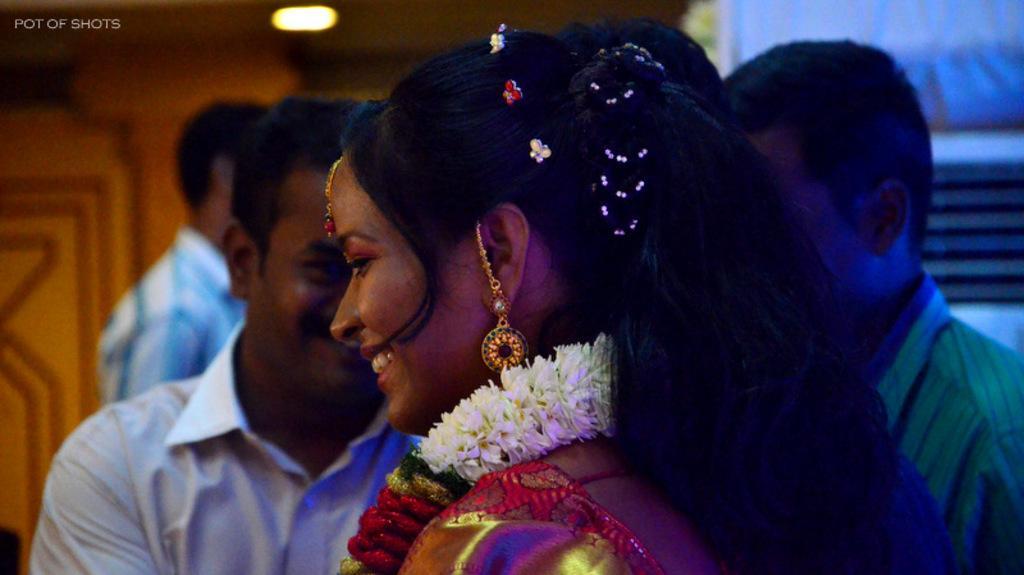Could you give a brief overview of what you see in this image? This picture seems to be clicked inside the room. In the foreground we can see a woman wearing a garland, smiling and seems to be standing and we can see the group of people seems to be standing. In the background we can see the light and many other objects. In the top left corner we can see the text on the image. 